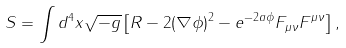Convert formula to latex. <formula><loc_0><loc_0><loc_500><loc_500>S = \int d ^ { 4 } x \sqrt { - g } \left [ R - 2 ( \nabla \phi ) ^ { 2 } - e ^ { - 2 a \phi } F _ { \mu \nu } F ^ { \mu \nu } \right ] ,</formula> 